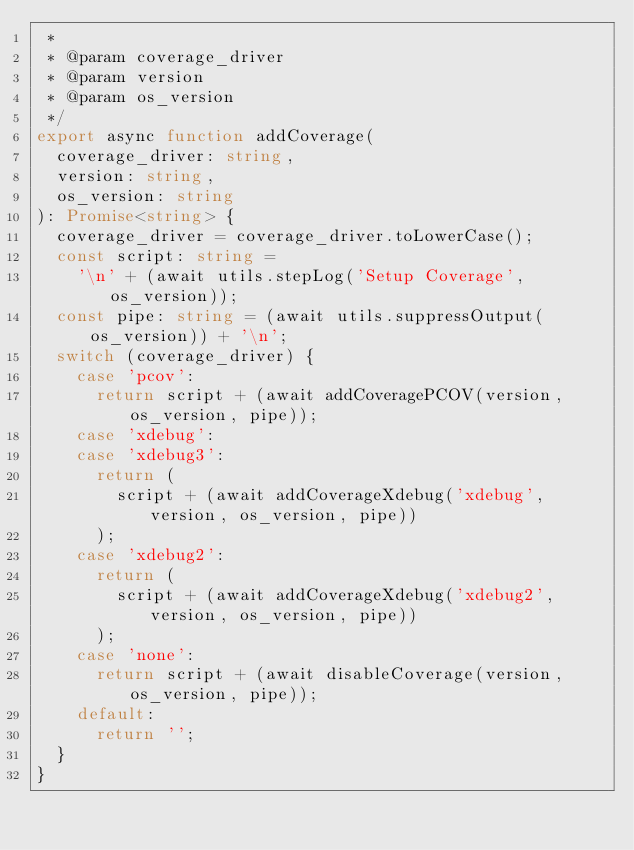<code> <loc_0><loc_0><loc_500><loc_500><_TypeScript_> *
 * @param coverage_driver
 * @param version
 * @param os_version
 */
export async function addCoverage(
  coverage_driver: string,
  version: string,
  os_version: string
): Promise<string> {
  coverage_driver = coverage_driver.toLowerCase();
  const script: string =
    '\n' + (await utils.stepLog('Setup Coverage', os_version));
  const pipe: string = (await utils.suppressOutput(os_version)) + '\n';
  switch (coverage_driver) {
    case 'pcov':
      return script + (await addCoveragePCOV(version, os_version, pipe));
    case 'xdebug':
    case 'xdebug3':
      return (
        script + (await addCoverageXdebug('xdebug', version, os_version, pipe))
      );
    case 'xdebug2':
      return (
        script + (await addCoverageXdebug('xdebug2', version, os_version, pipe))
      );
    case 'none':
      return script + (await disableCoverage(version, os_version, pipe));
    default:
      return '';
  }
}
</code> 